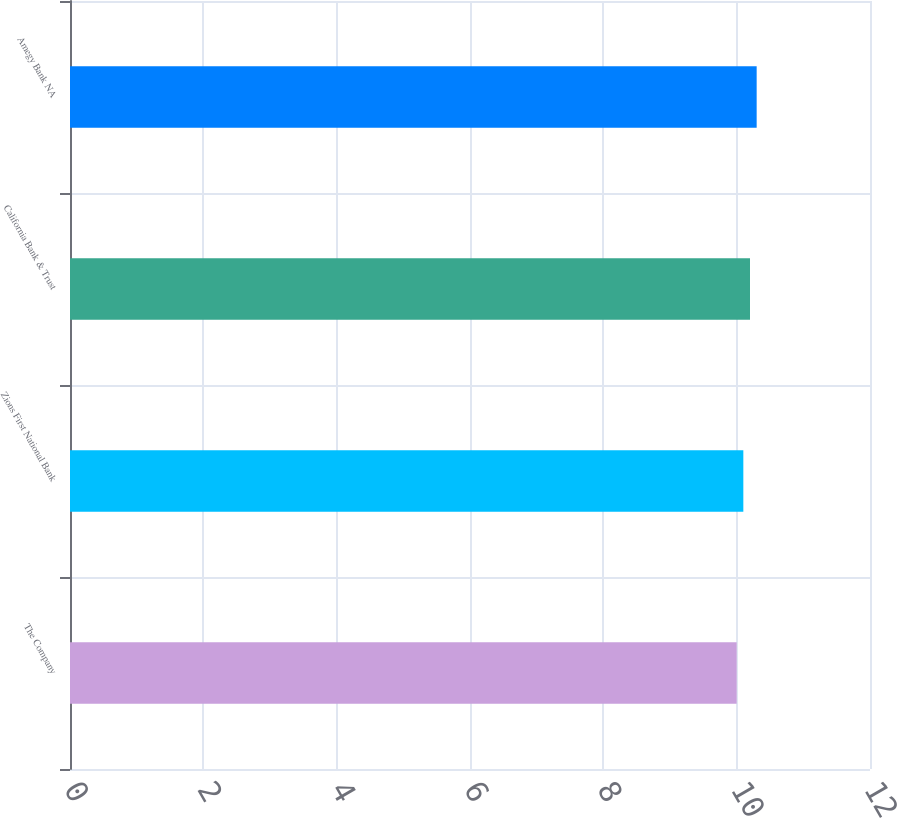Convert chart. <chart><loc_0><loc_0><loc_500><loc_500><bar_chart><fcel>The Company<fcel>Zions First National Bank<fcel>California Bank & Trust<fcel>Amegy Bank NA<nl><fcel>10<fcel>10.1<fcel>10.2<fcel>10.3<nl></chart> 